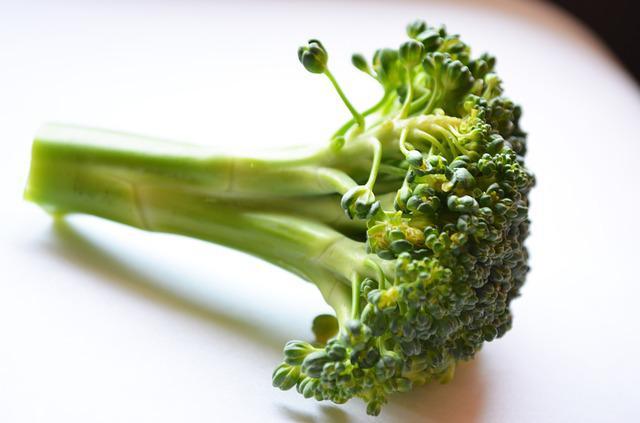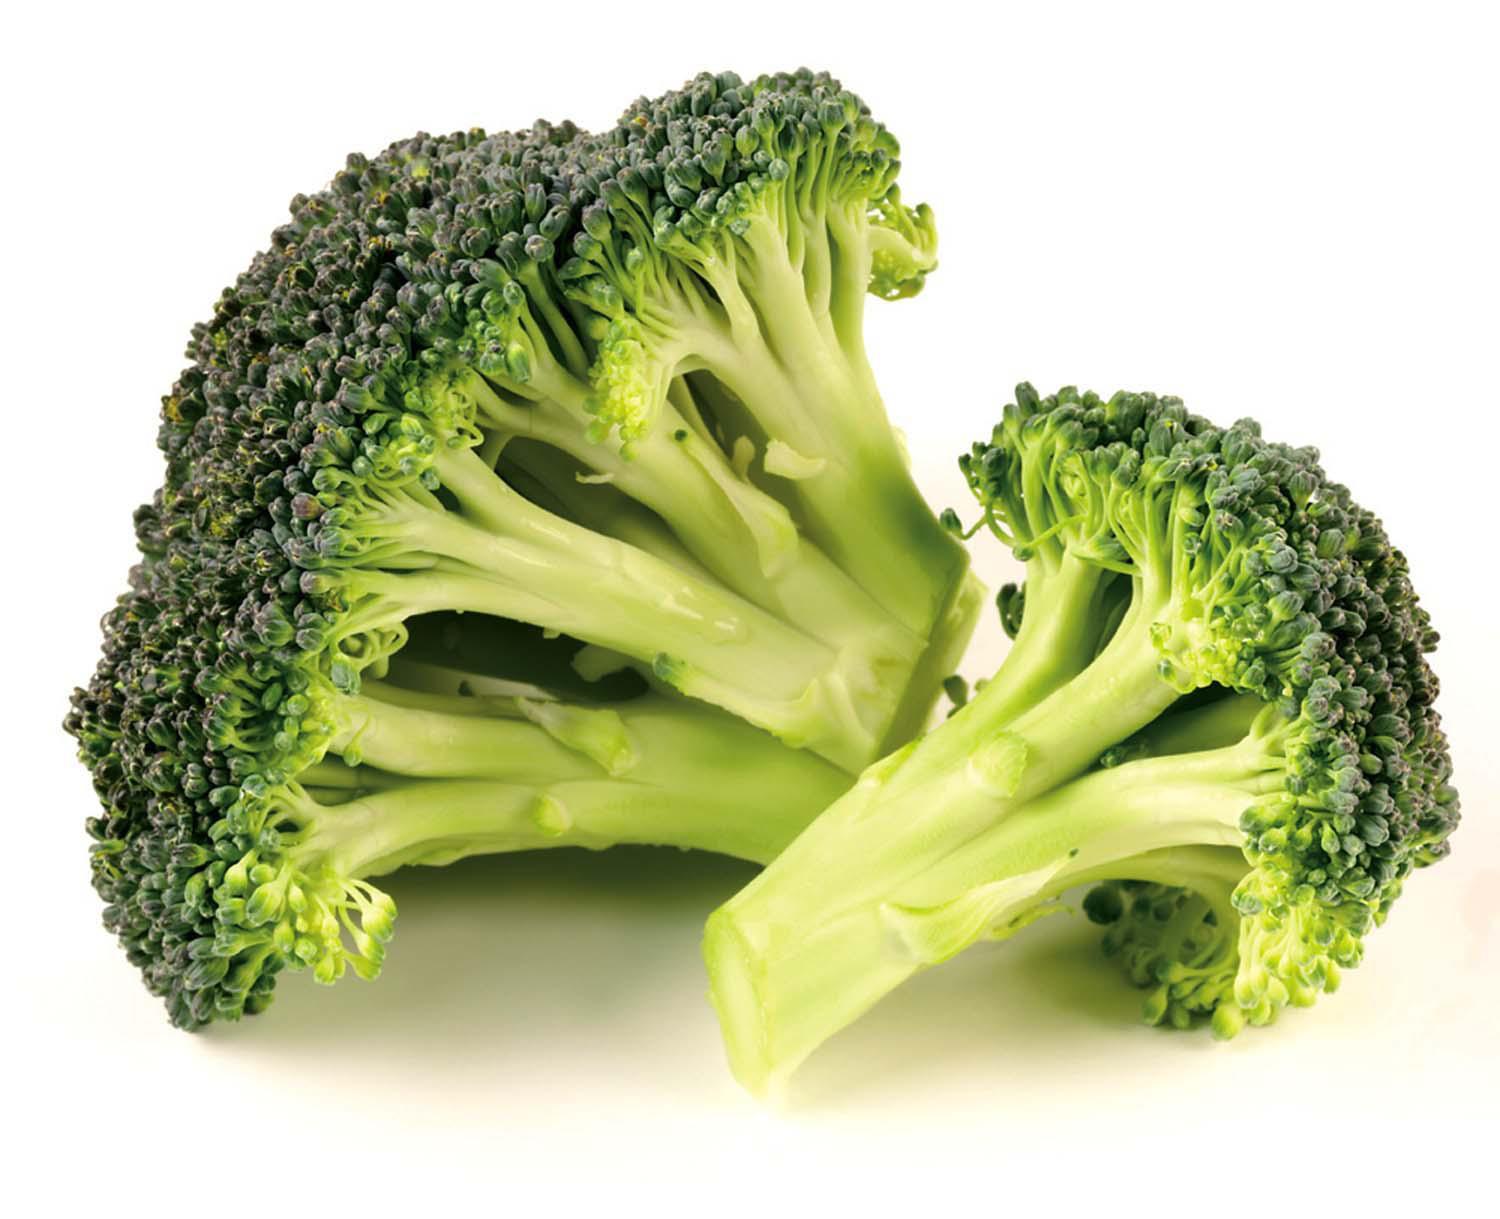The first image is the image on the left, the second image is the image on the right. For the images displayed, is the sentence "A total of three cut broccoli florets are shown." factually correct? Answer yes or no. Yes. 